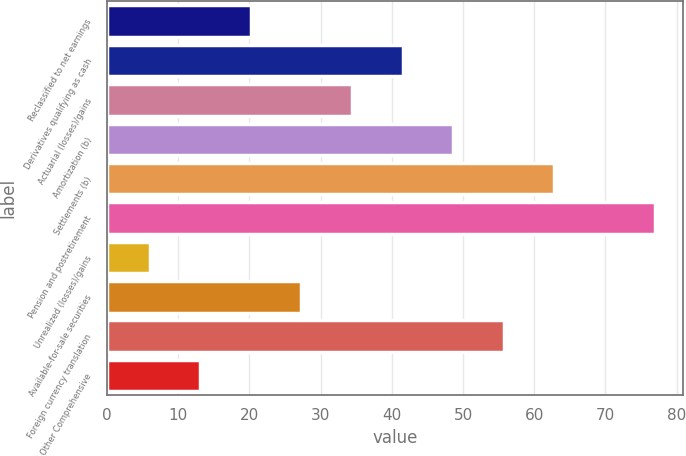<chart> <loc_0><loc_0><loc_500><loc_500><bar_chart><fcel>Reclassified to net earnings<fcel>Derivatives qualifying as cash<fcel>Actuarial (losses)/gains<fcel>Amortization (b)<fcel>Settlements (b)<fcel>Pension and postretirement<fcel>Unrealized (losses)/gains<fcel>Available-for-sale securities<fcel>Foreign currency translation<fcel>Total Other Comprehensive<nl><fcel>20.2<fcel>41.5<fcel>34.4<fcel>48.6<fcel>62.8<fcel>77<fcel>6<fcel>27.3<fcel>55.7<fcel>13.1<nl></chart> 